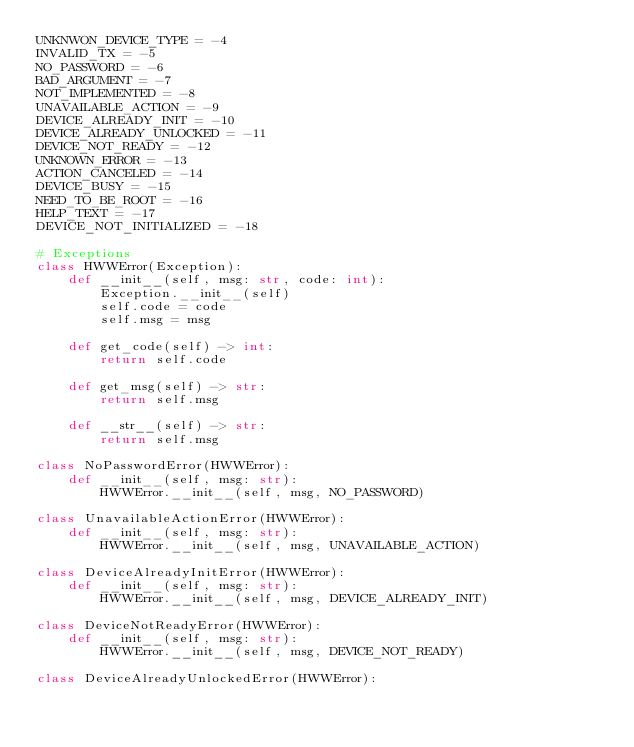<code> <loc_0><loc_0><loc_500><loc_500><_Python_>UNKNWON_DEVICE_TYPE = -4
INVALID_TX = -5
NO_PASSWORD = -6
BAD_ARGUMENT = -7
NOT_IMPLEMENTED = -8
UNAVAILABLE_ACTION = -9
DEVICE_ALREADY_INIT = -10
DEVICE_ALREADY_UNLOCKED = -11
DEVICE_NOT_READY = -12
UNKNOWN_ERROR = -13
ACTION_CANCELED = -14
DEVICE_BUSY = -15
NEED_TO_BE_ROOT = -16
HELP_TEXT = -17
DEVICE_NOT_INITIALIZED = -18

# Exceptions
class HWWError(Exception):
    def __init__(self, msg: str, code: int):
        Exception.__init__(self)
        self.code = code
        self.msg = msg

    def get_code(self) -> int:
        return self.code

    def get_msg(self) -> str:
        return self.msg

    def __str__(self) -> str:
        return self.msg

class NoPasswordError(HWWError):
    def __init__(self, msg: str):
        HWWError.__init__(self, msg, NO_PASSWORD)

class UnavailableActionError(HWWError):
    def __init__(self, msg: str):
        HWWError.__init__(self, msg, UNAVAILABLE_ACTION)

class DeviceAlreadyInitError(HWWError):
    def __init__(self, msg: str):
        HWWError.__init__(self, msg, DEVICE_ALREADY_INIT)

class DeviceNotReadyError(HWWError):
    def __init__(self, msg: str):
        HWWError.__init__(self, msg, DEVICE_NOT_READY)

class DeviceAlreadyUnlockedError(HWWError):</code> 